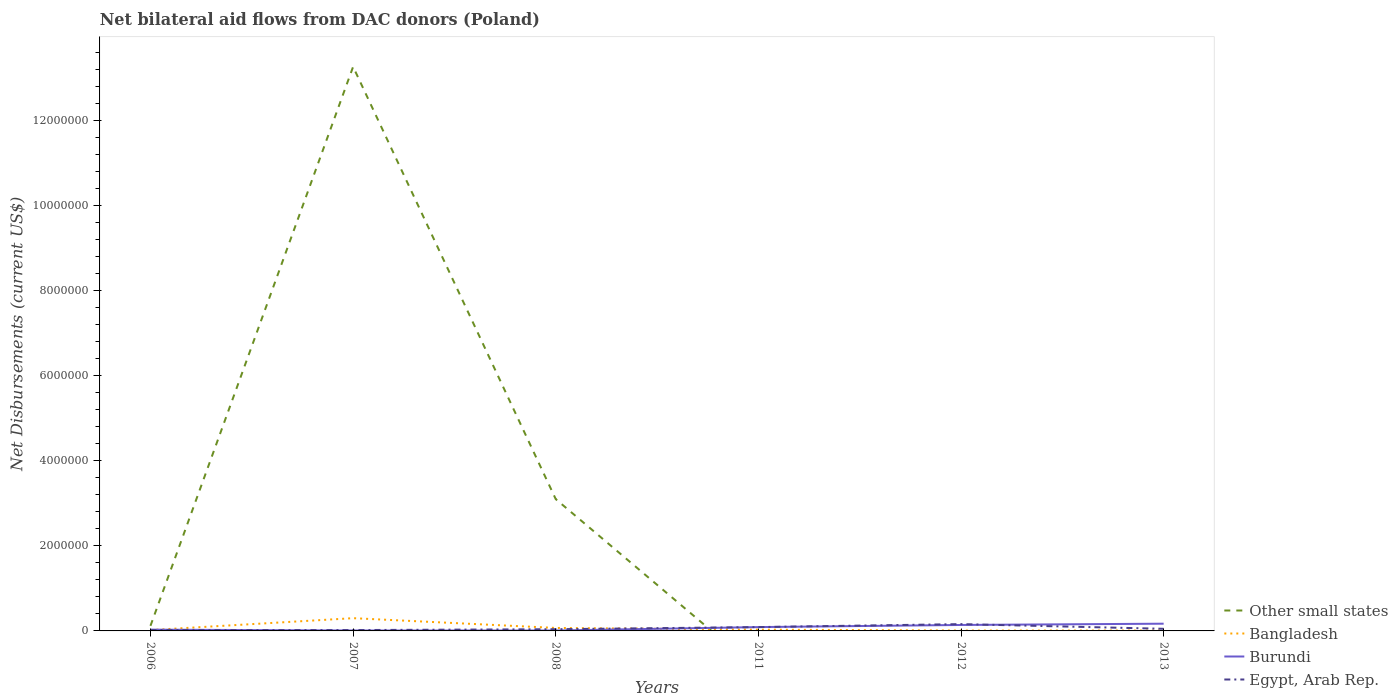Does the line corresponding to Other small states intersect with the line corresponding to Bangladesh?
Ensure brevity in your answer.  Yes. Across all years, what is the maximum net bilateral aid flows in Bangladesh?
Your answer should be very brief. 10000. What is the total net bilateral aid flows in Bangladesh in the graph?
Keep it short and to the point. 2.30e+05. What is the difference between the highest and the second highest net bilateral aid flows in Other small states?
Provide a succinct answer. 1.33e+07. What is the difference between the highest and the lowest net bilateral aid flows in Bangladesh?
Make the answer very short. 1. Is the net bilateral aid flows in Egypt, Arab Rep. strictly greater than the net bilateral aid flows in Other small states over the years?
Offer a very short reply. No. How many lines are there?
Offer a terse response. 4. Does the graph contain grids?
Offer a terse response. No. What is the title of the graph?
Provide a succinct answer. Net bilateral aid flows from DAC donors (Poland). Does "Uganda" appear as one of the legend labels in the graph?
Your answer should be compact. No. What is the label or title of the X-axis?
Offer a terse response. Years. What is the label or title of the Y-axis?
Provide a succinct answer. Net Disbursements (current US$). What is the Net Disbursements (current US$) in Bangladesh in 2006?
Provide a succinct answer. 2.00e+04. What is the Net Disbursements (current US$) of Burundi in 2006?
Offer a very short reply. 3.00e+04. What is the Net Disbursements (current US$) in Other small states in 2007?
Offer a terse response. 1.33e+07. What is the Net Disbursements (current US$) of Other small states in 2008?
Keep it short and to the point. 3.10e+06. What is the Net Disbursements (current US$) of Burundi in 2008?
Make the answer very short. 10000. What is the Net Disbursements (current US$) of Egypt, Arab Rep. in 2008?
Your response must be concise. 4.00e+04. What is the Net Disbursements (current US$) of Bangladesh in 2011?
Provide a short and direct response. 3.00e+04. What is the Net Disbursements (current US$) of Burundi in 2011?
Provide a short and direct response. 9.00e+04. What is the Net Disbursements (current US$) of Egypt, Arab Rep. in 2011?
Your answer should be compact. 9.00e+04. What is the Net Disbursements (current US$) of Other small states in 2012?
Offer a very short reply. 0. What is the Net Disbursements (current US$) of Bangladesh in 2012?
Offer a very short reply. 10000. What is the Net Disbursements (current US$) of Burundi in 2012?
Ensure brevity in your answer.  1.40e+05. What is the Net Disbursements (current US$) in Bangladesh in 2013?
Give a very brief answer. 10000. What is the Net Disbursements (current US$) of Egypt, Arab Rep. in 2013?
Give a very brief answer. 5.00e+04. Across all years, what is the maximum Net Disbursements (current US$) of Other small states?
Keep it short and to the point. 1.33e+07. Across all years, what is the maximum Net Disbursements (current US$) of Bangladesh?
Your answer should be compact. 3.00e+05. Across all years, what is the maximum Net Disbursements (current US$) in Burundi?
Offer a very short reply. 1.70e+05. What is the total Net Disbursements (current US$) in Other small states in the graph?
Give a very brief answer. 1.65e+07. What is the total Net Disbursements (current US$) of Bangladesh in the graph?
Give a very brief answer. 4.40e+05. What is the total Net Disbursements (current US$) of Burundi in the graph?
Your answer should be very brief. 4.50e+05. What is the difference between the Net Disbursements (current US$) in Other small states in 2006 and that in 2007?
Ensure brevity in your answer.  -1.32e+07. What is the difference between the Net Disbursements (current US$) in Bangladesh in 2006 and that in 2007?
Make the answer very short. -2.80e+05. What is the difference between the Net Disbursements (current US$) of Egypt, Arab Rep. in 2006 and that in 2007?
Give a very brief answer. 0. What is the difference between the Net Disbursements (current US$) of Other small states in 2006 and that in 2008?
Your answer should be compact. -2.98e+06. What is the difference between the Net Disbursements (current US$) of Bangladesh in 2006 and that in 2008?
Your response must be concise. -5.00e+04. What is the difference between the Net Disbursements (current US$) in Burundi in 2006 and that in 2008?
Your answer should be very brief. 2.00e+04. What is the difference between the Net Disbursements (current US$) in Egypt, Arab Rep. in 2006 and that in 2008?
Make the answer very short. -2.00e+04. What is the difference between the Net Disbursements (current US$) in Bangladesh in 2006 and that in 2011?
Your response must be concise. -10000. What is the difference between the Net Disbursements (current US$) of Burundi in 2006 and that in 2011?
Ensure brevity in your answer.  -6.00e+04. What is the difference between the Net Disbursements (current US$) in Burundi in 2006 and that in 2012?
Offer a very short reply. -1.10e+05. What is the difference between the Net Disbursements (current US$) in Burundi in 2006 and that in 2013?
Your response must be concise. -1.40e+05. What is the difference between the Net Disbursements (current US$) of Egypt, Arab Rep. in 2006 and that in 2013?
Provide a succinct answer. -3.00e+04. What is the difference between the Net Disbursements (current US$) of Other small states in 2007 and that in 2008?
Provide a succinct answer. 1.02e+07. What is the difference between the Net Disbursements (current US$) of Bangladesh in 2007 and that in 2008?
Your answer should be compact. 2.30e+05. What is the difference between the Net Disbursements (current US$) of Burundi in 2007 and that in 2008?
Offer a very short reply. 0. What is the difference between the Net Disbursements (current US$) of Bangladesh in 2007 and that in 2011?
Give a very brief answer. 2.70e+05. What is the difference between the Net Disbursements (current US$) of Egypt, Arab Rep. in 2007 and that in 2011?
Your answer should be very brief. -7.00e+04. What is the difference between the Net Disbursements (current US$) of Bangladesh in 2007 and that in 2012?
Your answer should be compact. 2.90e+05. What is the difference between the Net Disbursements (current US$) in Burundi in 2007 and that in 2012?
Keep it short and to the point. -1.30e+05. What is the difference between the Net Disbursements (current US$) in Bangladesh in 2007 and that in 2013?
Provide a succinct answer. 2.90e+05. What is the difference between the Net Disbursements (current US$) of Burundi in 2007 and that in 2013?
Provide a short and direct response. -1.60e+05. What is the difference between the Net Disbursements (current US$) of Egypt, Arab Rep. in 2007 and that in 2013?
Keep it short and to the point. -3.00e+04. What is the difference between the Net Disbursements (current US$) in Bangladesh in 2008 and that in 2012?
Ensure brevity in your answer.  6.00e+04. What is the difference between the Net Disbursements (current US$) of Egypt, Arab Rep. in 2008 and that in 2012?
Your response must be concise. -1.20e+05. What is the difference between the Net Disbursements (current US$) of Bangladesh in 2011 and that in 2012?
Offer a very short reply. 2.00e+04. What is the difference between the Net Disbursements (current US$) in Egypt, Arab Rep. in 2011 and that in 2012?
Provide a short and direct response. -7.00e+04. What is the difference between the Net Disbursements (current US$) of Bangladesh in 2011 and that in 2013?
Give a very brief answer. 2.00e+04. What is the difference between the Net Disbursements (current US$) of Bangladesh in 2012 and that in 2013?
Keep it short and to the point. 0. What is the difference between the Net Disbursements (current US$) in Burundi in 2012 and that in 2013?
Keep it short and to the point. -3.00e+04. What is the difference between the Net Disbursements (current US$) in Egypt, Arab Rep. in 2012 and that in 2013?
Your answer should be very brief. 1.10e+05. What is the difference between the Net Disbursements (current US$) of Other small states in 2006 and the Net Disbursements (current US$) of Bangladesh in 2007?
Make the answer very short. -1.80e+05. What is the difference between the Net Disbursements (current US$) in Other small states in 2006 and the Net Disbursements (current US$) in Burundi in 2007?
Give a very brief answer. 1.10e+05. What is the difference between the Net Disbursements (current US$) of Other small states in 2006 and the Net Disbursements (current US$) of Egypt, Arab Rep. in 2007?
Ensure brevity in your answer.  1.00e+05. What is the difference between the Net Disbursements (current US$) in Bangladesh in 2006 and the Net Disbursements (current US$) in Burundi in 2007?
Provide a short and direct response. 10000. What is the difference between the Net Disbursements (current US$) of Bangladesh in 2006 and the Net Disbursements (current US$) of Egypt, Arab Rep. in 2007?
Offer a terse response. 0. What is the difference between the Net Disbursements (current US$) in Other small states in 2006 and the Net Disbursements (current US$) in Bangladesh in 2008?
Provide a short and direct response. 5.00e+04. What is the difference between the Net Disbursements (current US$) of Bangladesh in 2006 and the Net Disbursements (current US$) of Burundi in 2008?
Offer a terse response. 10000. What is the difference between the Net Disbursements (current US$) of Bangladesh in 2006 and the Net Disbursements (current US$) of Egypt, Arab Rep. in 2008?
Keep it short and to the point. -2.00e+04. What is the difference between the Net Disbursements (current US$) in Burundi in 2006 and the Net Disbursements (current US$) in Egypt, Arab Rep. in 2008?
Keep it short and to the point. -10000. What is the difference between the Net Disbursements (current US$) in Other small states in 2006 and the Net Disbursements (current US$) in Bangladesh in 2011?
Provide a succinct answer. 9.00e+04. What is the difference between the Net Disbursements (current US$) of Bangladesh in 2006 and the Net Disbursements (current US$) of Burundi in 2011?
Keep it short and to the point. -7.00e+04. What is the difference between the Net Disbursements (current US$) of Burundi in 2006 and the Net Disbursements (current US$) of Egypt, Arab Rep. in 2011?
Your answer should be compact. -6.00e+04. What is the difference between the Net Disbursements (current US$) in Other small states in 2006 and the Net Disbursements (current US$) in Bangladesh in 2012?
Provide a short and direct response. 1.10e+05. What is the difference between the Net Disbursements (current US$) in Bangladesh in 2006 and the Net Disbursements (current US$) in Burundi in 2012?
Provide a succinct answer. -1.20e+05. What is the difference between the Net Disbursements (current US$) of Other small states in 2006 and the Net Disbursements (current US$) of Bangladesh in 2013?
Provide a short and direct response. 1.10e+05. What is the difference between the Net Disbursements (current US$) of Other small states in 2006 and the Net Disbursements (current US$) of Burundi in 2013?
Your answer should be very brief. -5.00e+04. What is the difference between the Net Disbursements (current US$) of Other small states in 2006 and the Net Disbursements (current US$) of Egypt, Arab Rep. in 2013?
Offer a very short reply. 7.00e+04. What is the difference between the Net Disbursements (current US$) of Bangladesh in 2006 and the Net Disbursements (current US$) of Burundi in 2013?
Your answer should be very brief. -1.50e+05. What is the difference between the Net Disbursements (current US$) in Bangladesh in 2006 and the Net Disbursements (current US$) in Egypt, Arab Rep. in 2013?
Offer a very short reply. -3.00e+04. What is the difference between the Net Disbursements (current US$) in Other small states in 2007 and the Net Disbursements (current US$) in Bangladesh in 2008?
Provide a succinct answer. 1.32e+07. What is the difference between the Net Disbursements (current US$) of Other small states in 2007 and the Net Disbursements (current US$) of Burundi in 2008?
Give a very brief answer. 1.33e+07. What is the difference between the Net Disbursements (current US$) of Other small states in 2007 and the Net Disbursements (current US$) of Egypt, Arab Rep. in 2008?
Give a very brief answer. 1.32e+07. What is the difference between the Net Disbursements (current US$) in Burundi in 2007 and the Net Disbursements (current US$) in Egypt, Arab Rep. in 2008?
Provide a succinct answer. -3.00e+04. What is the difference between the Net Disbursements (current US$) in Other small states in 2007 and the Net Disbursements (current US$) in Bangladesh in 2011?
Offer a terse response. 1.32e+07. What is the difference between the Net Disbursements (current US$) in Other small states in 2007 and the Net Disbursements (current US$) in Burundi in 2011?
Offer a terse response. 1.32e+07. What is the difference between the Net Disbursements (current US$) in Other small states in 2007 and the Net Disbursements (current US$) in Egypt, Arab Rep. in 2011?
Give a very brief answer. 1.32e+07. What is the difference between the Net Disbursements (current US$) in Bangladesh in 2007 and the Net Disbursements (current US$) in Burundi in 2011?
Your answer should be very brief. 2.10e+05. What is the difference between the Net Disbursements (current US$) of Burundi in 2007 and the Net Disbursements (current US$) of Egypt, Arab Rep. in 2011?
Your response must be concise. -8.00e+04. What is the difference between the Net Disbursements (current US$) of Other small states in 2007 and the Net Disbursements (current US$) of Bangladesh in 2012?
Ensure brevity in your answer.  1.33e+07. What is the difference between the Net Disbursements (current US$) of Other small states in 2007 and the Net Disbursements (current US$) of Burundi in 2012?
Give a very brief answer. 1.31e+07. What is the difference between the Net Disbursements (current US$) of Other small states in 2007 and the Net Disbursements (current US$) of Egypt, Arab Rep. in 2012?
Provide a succinct answer. 1.31e+07. What is the difference between the Net Disbursements (current US$) of Other small states in 2007 and the Net Disbursements (current US$) of Bangladesh in 2013?
Your response must be concise. 1.33e+07. What is the difference between the Net Disbursements (current US$) in Other small states in 2007 and the Net Disbursements (current US$) in Burundi in 2013?
Your response must be concise. 1.31e+07. What is the difference between the Net Disbursements (current US$) of Other small states in 2007 and the Net Disbursements (current US$) of Egypt, Arab Rep. in 2013?
Your answer should be compact. 1.32e+07. What is the difference between the Net Disbursements (current US$) in Bangladesh in 2007 and the Net Disbursements (current US$) in Egypt, Arab Rep. in 2013?
Give a very brief answer. 2.50e+05. What is the difference between the Net Disbursements (current US$) of Burundi in 2007 and the Net Disbursements (current US$) of Egypt, Arab Rep. in 2013?
Keep it short and to the point. -4.00e+04. What is the difference between the Net Disbursements (current US$) of Other small states in 2008 and the Net Disbursements (current US$) of Bangladesh in 2011?
Your answer should be very brief. 3.07e+06. What is the difference between the Net Disbursements (current US$) in Other small states in 2008 and the Net Disbursements (current US$) in Burundi in 2011?
Make the answer very short. 3.01e+06. What is the difference between the Net Disbursements (current US$) of Other small states in 2008 and the Net Disbursements (current US$) of Egypt, Arab Rep. in 2011?
Provide a succinct answer. 3.01e+06. What is the difference between the Net Disbursements (current US$) in Bangladesh in 2008 and the Net Disbursements (current US$) in Egypt, Arab Rep. in 2011?
Make the answer very short. -2.00e+04. What is the difference between the Net Disbursements (current US$) of Other small states in 2008 and the Net Disbursements (current US$) of Bangladesh in 2012?
Your answer should be very brief. 3.09e+06. What is the difference between the Net Disbursements (current US$) of Other small states in 2008 and the Net Disbursements (current US$) of Burundi in 2012?
Offer a very short reply. 2.96e+06. What is the difference between the Net Disbursements (current US$) in Other small states in 2008 and the Net Disbursements (current US$) in Egypt, Arab Rep. in 2012?
Offer a terse response. 2.94e+06. What is the difference between the Net Disbursements (current US$) in Bangladesh in 2008 and the Net Disbursements (current US$) in Burundi in 2012?
Ensure brevity in your answer.  -7.00e+04. What is the difference between the Net Disbursements (current US$) of Other small states in 2008 and the Net Disbursements (current US$) of Bangladesh in 2013?
Make the answer very short. 3.09e+06. What is the difference between the Net Disbursements (current US$) in Other small states in 2008 and the Net Disbursements (current US$) in Burundi in 2013?
Your response must be concise. 2.93e+06. What is the difference between the Net Disbursements (current US$) in Other small states in 2008 and the Net Disbursements (current US$) in Egypt, Arab Rep. in 2013?
Ensure brevity in your answer.  3.05e+06. What is the difference between the Net Disbursements (current US$) of Bangladesh in 2008 and the Net Disbursements (current US$) of Egypt, Arab Rep. in 2013?
Your answer should be very brief. 2.00e+04. What is the difference between the Net Disbursements (current US$) of Bangladesh in 2011 and the Net Disbursements (current US$) of Burundi in 2013?
Give a very brief answer. -1.40e+05. What is the difference between the Net Disbursements (current US$) of Bangladesh in 2011 and the Net Disbursements (current US$) of Egypt, Arab Rep. in 2013?
Give a very brief answer. -2.00e+04. What is the difference between the Net Disbursements (current US$) in Burundi in 2011 and the Net Disbursements (current US$) in Egypt, Arab Rep. in 2013?
Your response must be concise. 4.00e+04. What is the difference between the Net Disbursements (current US$) in Bangladesh in 2012 and the Net Disbursements (current US$) in Burundi in 2013?
Make the answer very short. -1.60e+05. What is the average Net Disbursements (current US$) of Other small states per year?
Offer a very short reply. 2.75e+06. What is the average Net Disbursements (current US$) of Bangladesh per year?
Offer a terse response. 7.33e+04. What is the average Net Disbursements (current US$) in Burundi per year?
Your answer should be compact. 7.50e+04. What is the average Net Disbursements (current US$) in Egypt, Arab Rep. per year?
Give a very brief answer. 6.33e+04. In the year 2006, what is the difference between the Net Disbursements (current US$) in Bangladesh and Net Disbursements (current US$) in Burundi?
Your answer should be compact. -10000. In the year 2006, what is the difference between the Net Disbursements (current US$) in Bangladesh and Net Disbursements (current US$) in Egypt, Arab Rep.?
Your answer should be very brief. 0. In the year 2007, what is the difference between the Net Disbursements (current US$) of Other small states and Net Disbursements (current US$) of Bangladesh?
Keep it short and to the point. 1.30e+07. In the year 2007, what is the difference between the Net Disbursements (current US$) in Other small states and Net Disbursements (current US$) in Burundi?
Your answer should be compact. 1.33e+07. In the year 2007, what is the difference between the Net Disbursements (current US$) in Other small states and Net Disbursements (current US$) in Egypt, Arab Rep.?
Your answer should be compact. 1.32e+07. In the year 2007, what is the difference between the Net Disbursements (current US$) of Burundi and Net Disbursements (current US$) of Egypt, Arab Rep.?
Provide a succinct answer. -10000. In the year 2008, what is the difference between the Net Disbursements (current US$) of Other small states and Net Disbursements (current US$) of Bangladesh?
Provide a short and direct response. 3.03e+06. In the year 2008, what is the difference between the Net Disbursements (current US$) of Other small states and Net Disbursements (current US$) of Burundi?
Provide a succinct answer. 3.09e+06. In the year 2008, what is the difference between the Net Disbursements (current US$) of Other small states and Net Disbursements (current US$) of Egypt, Arab Rep.?
Your answer should be compact. 3.06e+06. In the year 2008, what is the difference between the Net Disbursements (current US$) in Burundi and Net Disbursements (current US$) in Egypt, Arab Rep.?
Ensure brevity in your answer.  -3.00e+04. In the year 2011, what is the difference between the Net Disbursements (current US$) of Bangladesh and Net Disbursements (current US$) of Burundi?
Give a very brief answer. -6.00e+04. In the year 2011, what is the difference between the Net Disbursements (current US$) of Burundi and Net Disbursements (current US$) of Egypt, Arab Rep.?
Provide a succinct answer. 0. In the year 2012, what is the difference between the Net Disbursements (current US$) in Burundi and Net Disbursements (current US$) in Egypt, Arab Rep.?
Ensure brevity in your answer.  -2.00e+04. In the year 2013, what is the difference between the Net Disbursements (current US$) in Bangladesh and Net Disbursements (current US$) in Burundi?
Your answer should be very brief. -1.60e+05. In the year 2013, what is the difference between the Net Disbursements (current US$) of Bangladesh and Net Disbursements (current US$) of Egypt, Arab Rep.?
Give a very brief answer. -4.00e+04. What is the ratio of the Net Disbursements (current US$) in Other small states in 2006 to that in 2007?
Provide a succinct answer. 0.01. What is the ratio of the Net Disbursements (current US$) of Bangladesh in 2006 to that in 2007?
Ensure brevity in your answer.  0.07. What is the ratio of the Net Disbursements (current US$) in Burundi in 2006 to that in 2007?
Give a very brief answer. 3. What is the ratio of the Net Disbursements (current US$) of Egypt, Arab Rep. in 2006 to that in 2007?
Provide a short and direct response. 1. What is the ratio of the Net Disbursements (current US$) of Other small states in 2006 to that in 2008?
Offer a terse response. 0.04. What is the ratio of the Net Disbursements (current US$) of Bangladesh in 2006 to that in 2008?
Ensure brevity in your answer.  0.29. What is the ratio of the Net Disbursements (current US$) of Burundi in 2006 to that in 2008?
Offer a very short reply. 3. What is the ratio of the Net Disbursements (current US$) in Egypt, Arab Rep. in 2006 to that in 2008?
Your answer should be compact. 0.5. What is the ratio of the Net Disbursements (current US$) in Burundi in 2006 to that in 2011?
Give a very brief answer. 0.33. What is the ratio of the Net Disbursements (current US$) in Egypt, Arab Rep. in 2006 to that in 2011?
Give a very brief answer. 0.22. What is the ratio of the Net Disbursements (current US$) in Bangladesh in 2006 to that in 2012?
Ensure brevity in your answer.  2. What is the ratio of the Net Disbursements (current US$) of Burundi in 2006 to that in 2012?
Offer a terse response. 0.21. What is the ratio of the Net Disbursements (current US$) of Egypt, Arab Rep. in 2006 to that in 2012?
Offer a terse response. 0.12. What is the ratio of the Net Disbursements (current US$) in Burundi in 2006 to that in 2013?
Provide a succinct answer. 0.18. What is the ratio of the Net Disbursements (current US$) in Egypt, Arab Rep. in 2006 to that in 2013?
Offer a terse response. 0.4. What is the ratio of the Net Disbursements (current US$) of Other small states in 2007 to that in 2008?
Your answer should be very brief. 4.28. What is the ratio of the Net Disbursements (current US$) of Bangladesh in 2007 to that in 2008?
Offer a very short reply. 4.29. What is the ratio of the Net Disbursements (current US$) of Burundi in 2007 to that in 2008?
Your response must be concise. 1. What is the ratio of the Net Disbursements (current US$) of Egypt, Arab Rep. in 2007 to that in 2011?
Offer a terse response. 0.22. What is the ratio of the Net Disbursements (current US$) of Burundi in 2007 to that in 2012?
Provide a succinct answer. 0.07. What is the ratio of the Net Disbursements (current US$) in Egypt, Arab Rep. in 2007 to that in 2012?
Provide a succinct answer. 0.12. What is the ratio of the Net Disbursements (current US$) in Burundi in 2007 to that in 2013?
Ensure brevity in your answer.  0.06. What is the ratio of the Net Disbursements (current US$) in Egypt, Arab Rep. in 2007 to that in 2013?
Make the answer very short. 0.4. What is the ratio of the Net Disbursements (current US$) of Bangladesh in 2008 to that in 2011?
Keep it short and to the point. 2.33. What is the ratio of the Net Disbursements (current US$) of Burundi in 2008 to that in 2011?
Provide a succinct answer. 0.11. What is the ratio of the Net Disbursements (current US$) of Egypt, Arab Rep. in 2008 to that in 2011?
Your response must be concise. 0.44. What is the ratio of the Net Disbursements (current US$) of Burundi in 2008 to that in 2012?
Keep it short and to the point. 0.07. What is the ratio of the Net Disbursements (current US$) in Egypt, Arab Rep. in 2008 to that in 2012?
Provide a short and direct response. 0.25. What is the ratio of the Net Disbursements (current US$) in Bangladesh in 2008 to that in 2013?
Your answer should be very brief. 7. What is the ratio of the Net Disbursements (current US$) of Burundi in 2008 to that in 2013?
Offer a terse response. 0.06. What is the ratio of the Net Disbursements (current US$) of Egypt, Arab Rep. in 2008 to that in 2013?
Give a very brief answer. 0.8. What is the ratio of the Net Disbursements (current US$) in Bangladesh in 2011 to that in 2012?
Your response must be concise. 3. What is the ratio of the Net Disbursements (current US$) in Burundi in 2011 to that in 2012?
Your answer should be compact. 0.64. What is the ratio of the Net Disbursements (current US$) in Egypt, Arab Rep. in 2011 to that in 2012?
Your response must be concise. 0.56. What is the ratio of the Net Disbursements (current US$) in Burundi in 2011 to that in 2013?
Your response must be concise. 0.53. What is the ratio of the Net Disbursements (current US$) in Egypt, Arab Rep. in 2011 to that in 2013?
Provide a succinct answer. 1.8. What is the ratio of the Net Disbursements (current US$) of Burundi in 2012 to that in 2013?
Your answer should be very brief. 0.82. What is the ratio of the Net Disbursements (current US$) of Egypt, Arab Rep. in 2012 to that in 2013?
Offer a terse response. 3.2. What is the difference between the highest and the second highest Net Disbursements (current US$) of Other small states?
Offer a terse response. 1.02e+07. What is the difference between the highest and the lowest Net Disbursements (current US$) in Other small states?
Your answer should be very brief. 1.33e+07. What is the difference between the highest and the lowest Net Disbursements (current US$) in Burundi?
Your answer should be very brief. 1.60e+05. 